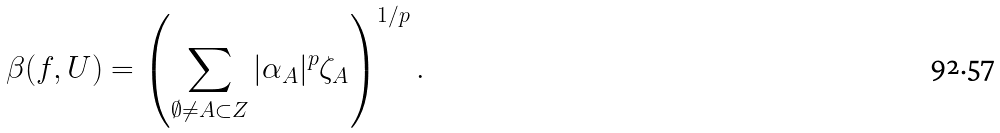<formula> <loc_0><loc_0><loc_500><loc_500>\beta ( f , U ) = \left ( \sum _ { \emptyset \neq A \subset Z } | \alpha _ { A } | ^ { p } \zeta _ { A } \right ) ^ { 1 / p } .</formula> 